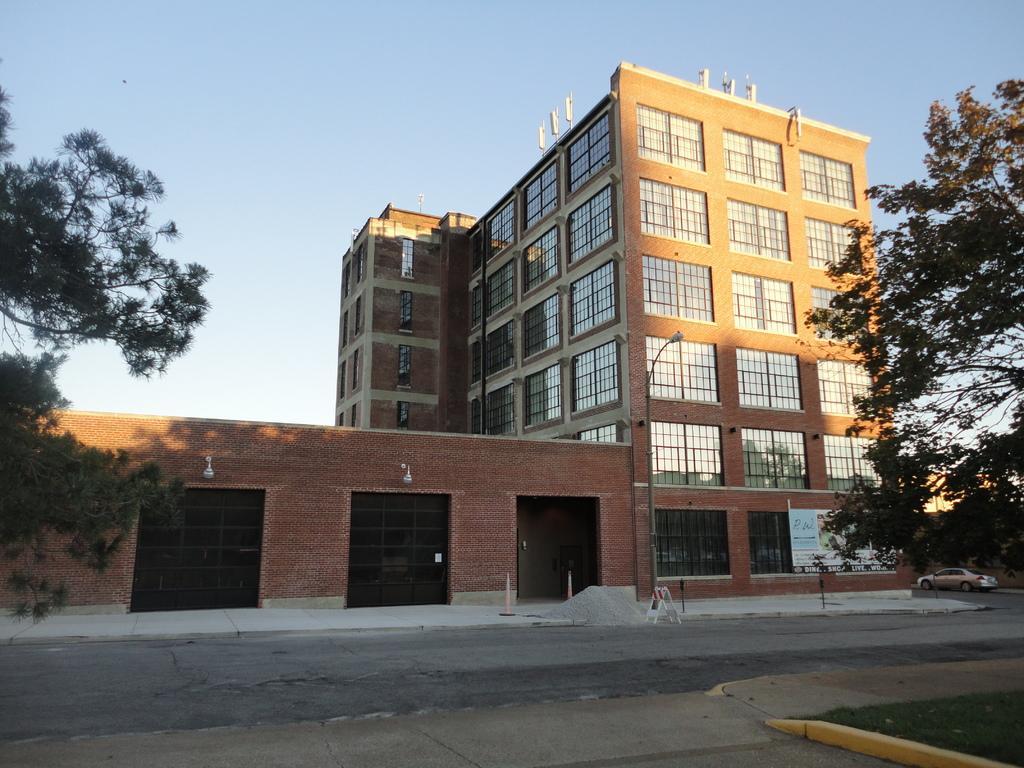Can you describe this image briefly? In this picture there are buildings on the right side of the image and there are trees on the right and left side of the image, it seems to be the view of a road. 